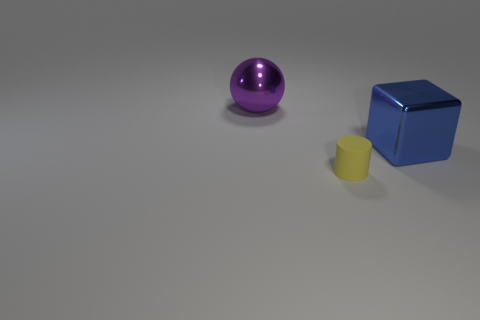Add 1 large shiny objects. How many objects exist? 4 Subtract all cubes. How many objects are left? 2 Subtract 0 red cubes. How many objects are left? 3 Subtract all purple objects. Subtract all small blue cylinders. How many objects are left? 2 Add 2 blue metallic blocks. How many blue metallic blocks are left? 3 Add 2 small cyan metallic objects. How many small cyan metallic objects exist? 2 